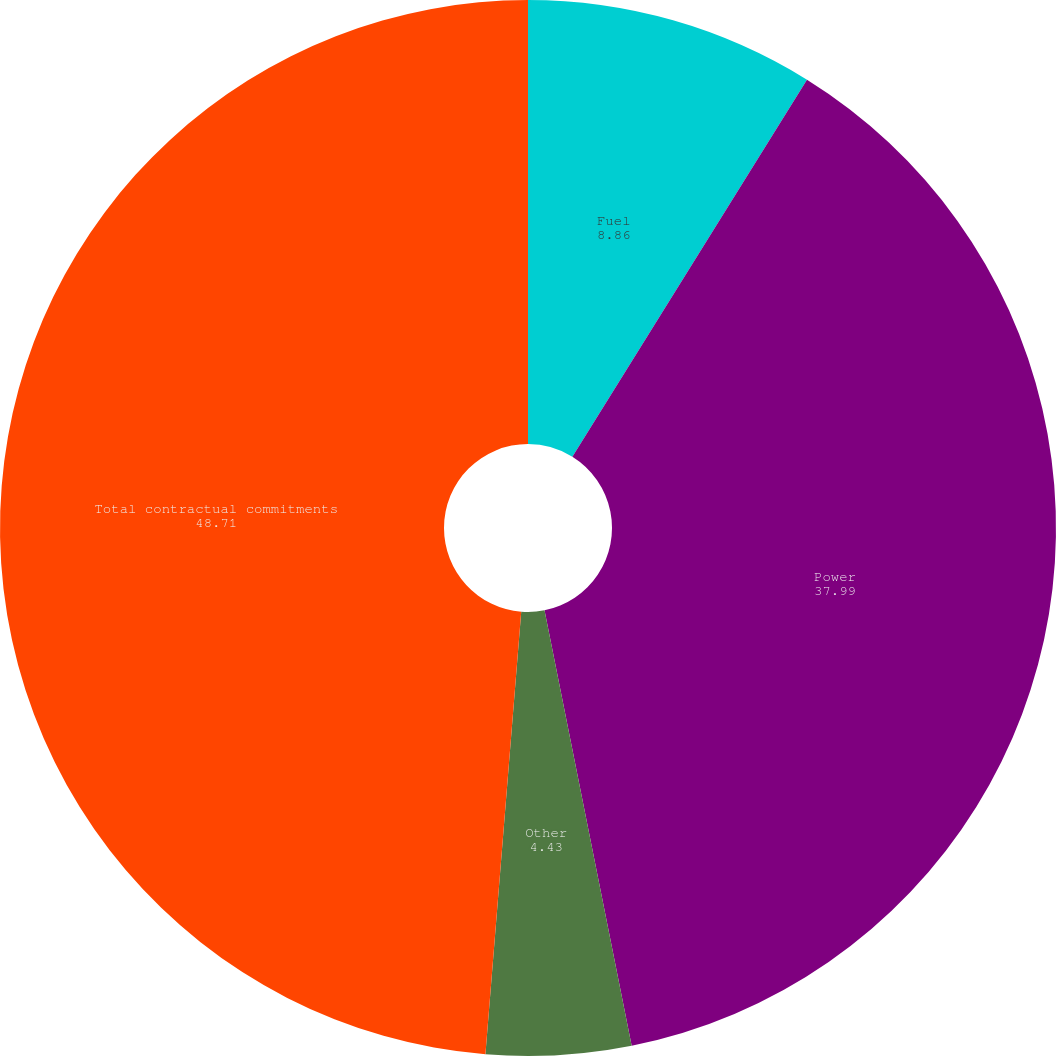Convert chart to OTSL. <chart><loc_0><loc_0><loc_500><loc_500><pie_chart><fcel>Fuel<fcel>Power<fcel>Other<fcel>Total contractual commitments<nl><fcel>8.86%<fcel>37.99%<fcel>4.43%<fcel>48.71%<nl></chart> 